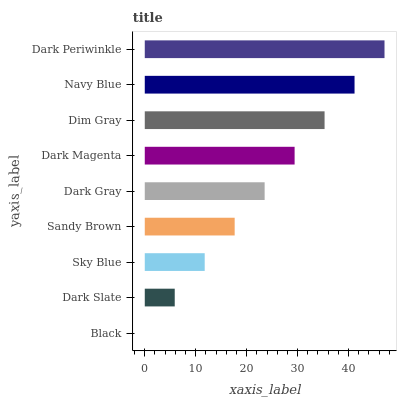Is Black the minimum?
Answer yes or no. Yes. Is Dark Periwinkle the maximum?
Answer yes or no. Yes. Is Dark Slate the minimum?
Answer yes or no. No. Is Dark Slate the maximum?
Answer yes or no. No. Is Dark Slate greater than Black?
Answer yes or no. Yes. Is Black less than Dark Slate?
Answer yes or no. Yes. Is Black greater than Dark Slate?
Answer yes or no. No. Is Dark Slate less than Black?
Answer yes or no. No. Is Dark Gray the high median?
Answer yes or no. Yes. Is Dark Gray the low median?
Answer yes or no. Yes. Is Dark Magenta the high median?
Answer yes or no. No. Is Black the low median?
Answer yes or no. No. 